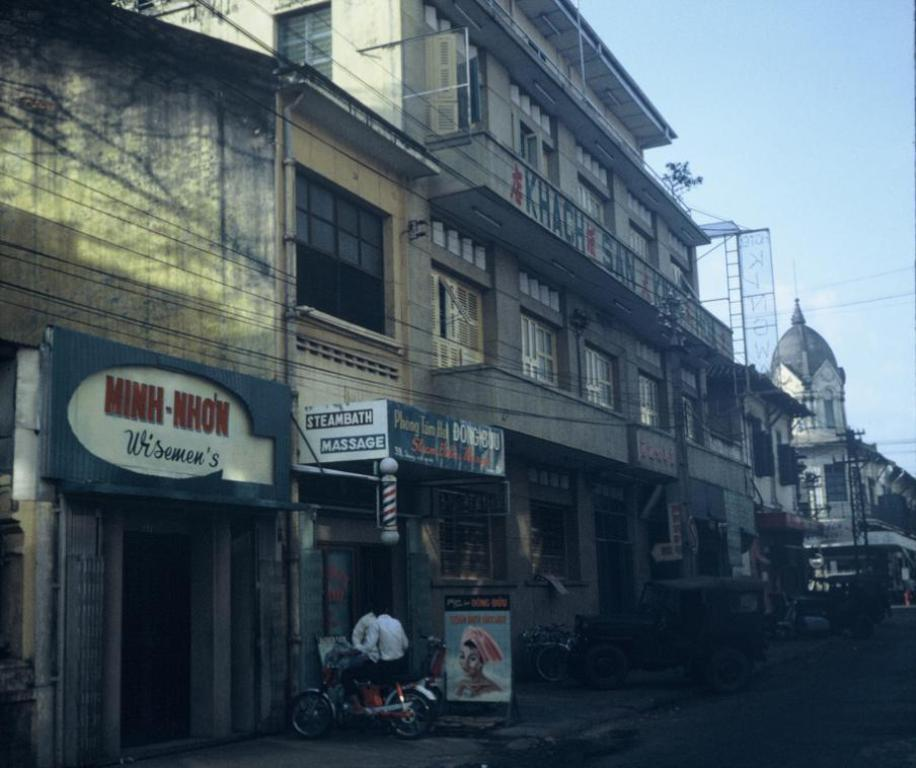What is the main feature of the image? There is a road in the image. What else can be seen near the road? There are vehicles beside the road. What other structure is visible in the image? There is a tower in the image. What can be seen in the distance in the image? There are buildings in the background of the image, and the sky is visible in the background as well. Can you tell me how many bulbs are hanging from the tower in the image? There is no mention of bulbs in the image; the tower is the only structure mentioned, and no details about its features are provided. Is there a horse running along the road in the image? There is no horse present in the image; the main subjects are the road, vehicles, tower, and background elements. 